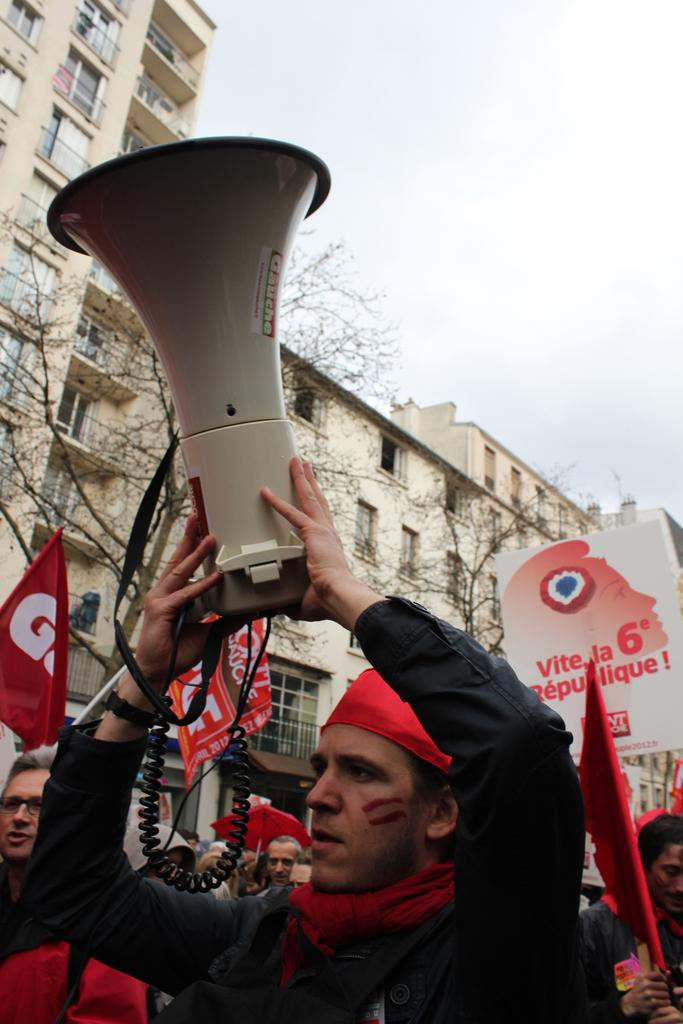How many people are in the group visible in the image? There is a group of people in the image, but the exact number cannot be determined from the provided facts. What can be seen hanging in the image? There are banners in the image. What type of illumination is present in the image? There are lights in the image. What type of structures are visible in the image? There are buildings with windows in the image. What type of vegetation is present in the image? There are trees in the image. What is visible in the background of the image? The sky is visible in the background of the image. How many snakes are slithering around the banners in the image? There are no snakes present in the image; it features a group of people, banners, lights, buildings, trees, and the sky. What type of riddle can be solved by looking at the buildings in the image? There is no riddle associated with the buildings in the image; they are simply structures with windows. 